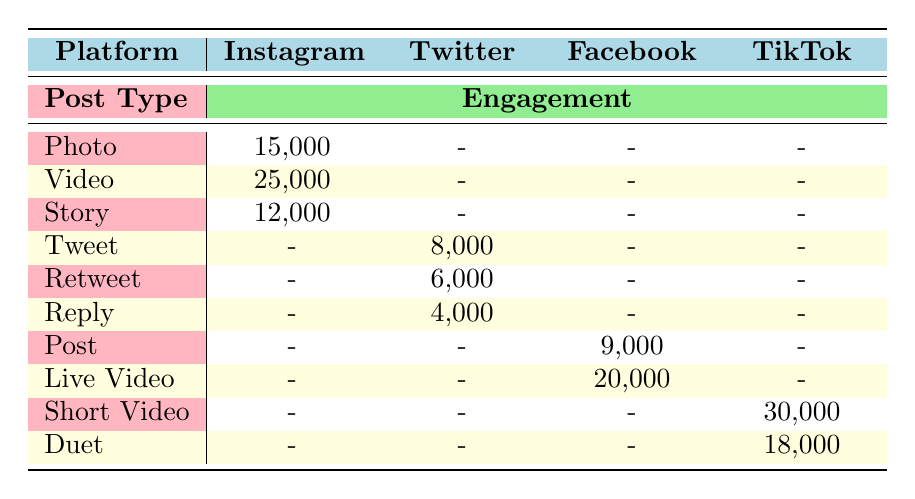What platform has the highest engagement for photo posts? The highest engagement for photo posts can be found in the Instagram column, which has an engagement of 15,000 for the photo post type. No other platforms have photo data.
Answer: Instagram What is the total engagement for Twitter post types? The total engagement for Twitter can be calculated by adding the engagements from tweets, retweets, and replies: 8,000 (Tweet) + 6,000 (Retweet) + 4,000 (Reply) = 18,000.
Answer: 18,000 Which post type on TikTok has the lowest engagement? The TikTok post types are Short Video with 30,000 engagement and Duet with 18,000 engagement. Duet has the lowest engagement of the two, which is 18,000.
Answer: Duet Is the engagement for Facebook Live Video higher than that for Instagram Video? The engagement for Facebook Live Video is 20,000 and for Instagram Video, it is 25,000. Since 20,000 < 25,000, the engagement for Facebook Live Video is not higher.
Answer: No What is the average engagement for Instagram posts? The engagements for Instagram are 15,000 (Photo), 25,000 (Video), and 12,000 (Story). To find the average, we sum these values: 15,000 + 25,000 + 12,000 = 52,000, and divide by the number of posts: 52,000 / 3 = 17,333.33.
Answer: 17,333.33 Which post type across all platforms has the highest engagement? The highest engagement number across all post types is 30,000, found in TikTok under the Short Video category.
Answer: Short Video How does the engagement for Instagram Story compare to Twitter Tweet? The engagement for Instagram Story is 12,000, while for Twitter Tweet, it is 8,000. Since 12,000 > 8,000, Instagram's engagement for Story is higher.
Answer: Higher What is the total engagement for all post types on TikTok? The engagement for TikTok comprises Short Video (30,000) and Duet (18,000), so the total engagement would be 30,000 + 18,000 = 48,000.
Answer: 48,000 